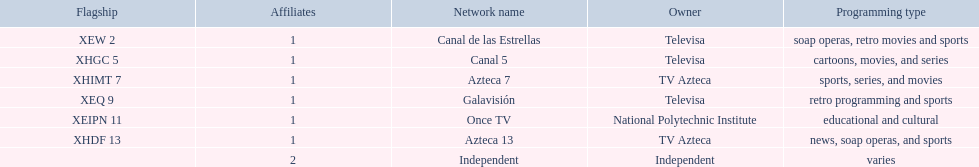Which owner only owns one network? National Polytechnic Institute, Independent. Of those, what is the network name? Once TV, Independent. Of those, which programming type is educational and cultural? Once TV. 